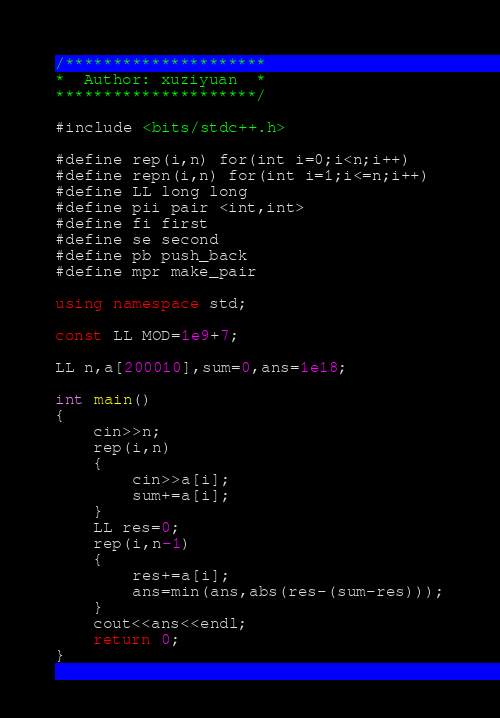Convert code to text. <code><loc_0><loc_0><loc_500><loc_500><_C++_>/*********************
*  Author: xuziyuan  * 
*********************/

#include <bits/stdc++.h>

#define rep(i,n) for(int i=0;i<n;i++)
#define repn(i,n) for(int i=1;i<=n;i++)
#define LL long long
#define pii pair <int,int>
#define fi first
#define se second
#define pb push_back
#define mpr make_pair

using namespace std;

const LL MOD=1e9+7;

LL n,a[200010],sum=0,ans=1e18;

int main()
{
	cin>>n;
	rep(i,n)
	{
		cin>>a[i];
		sum+=a[i];
	}
	LL res=0;
	rep(i,n-1)
	{
		res+=a[i];
		ans=min(ans,abs(res-(sum-res)));
	}
	cout<<ans<<endl;
	return 0;
}</code> 